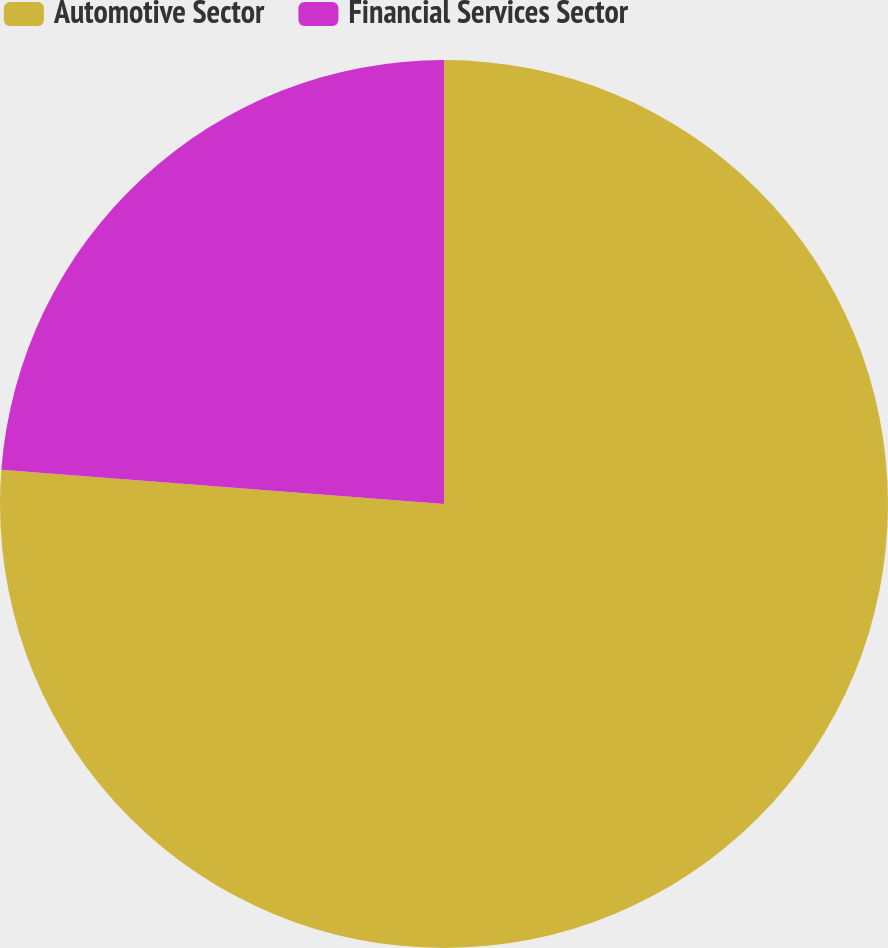Convert chart. <chart><loc_0><loc_0><loc_500><loc_500><pie_chart><fcel>Automotive Sector<fcel>Financial Services Sector<nl><fcel>76.23%<fcel>23.77%<nl></chart> 